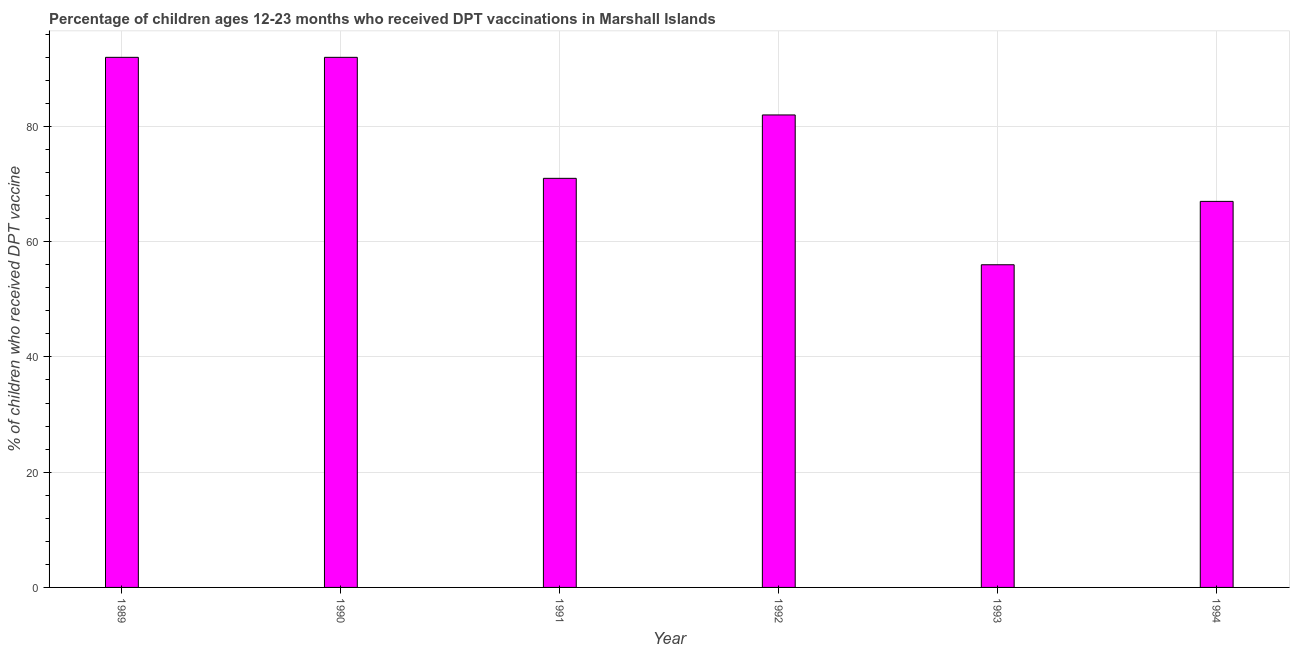Does the graph contain any zero values?
Make the answer very short. No. Does the graph contain grids?
Your answer should be very brief. Yes. What is the title of the graph?
Offer a very short reply. Percentage of children ages 12-23 months who received DPT vaccinations in Marshall Islands. What is the label or title of the Y-axis?
Offer a very short reply. % of children who received DPT vaccine. What is the percentage of children who received dpt vaccine in 1993?
Your answer should be compact. 56. Across all years, what is the maximum percentage of children who received dpt vaccine?
Offer a very short reply. 92. In which year was the percentage of children who received dpt vaccine maximum?
Keep it short and to the point. 1989. In which year was the percentage of children who received dpt vaccine minimum?
Give a very brief answer. 1993. What is the sum of the percentage of children who received dpt vaccine?
Your response must be concise. 460. What is the median percentage of children who received dpt vaccine?
Your response must be concise. 76.5. What is the ratio of the percentage of children who received dpt vaccine in 1989 to that in 1991?
Offer a very short reply. 1.3. What is the difference between the highest and the second highest percentage of children who received dpt vaccine?
Offer a very short reply. 0. Are the values on the major ticks of Y-axis written in scientific E-notation?
Offer a very short reply. No. What is the % of children who received DPT vaccine in 1989?
Provide a short and direct response. 92. What is the % of children who received DPT vaccine in 1990?
Give a very brief answer. 92. What is the % of children who received DPT vaccine of 1991?
Give a very brief answer. 71. What is the % of children who received DPT vaccine of 1993?
Your response must be concise. 56. What is the % of children who received DPT vaccine in 1994?
Give a very brief answer. 67. What is the difference between the % of children who received DPT vaccine in 1989 and 1990?
Make the answer very short. 0. What is the difference between the % of children who received DPT vaccine in 1989 and 1993?
Give a very brief answer. 36. What is the difference between the % of children who received DPT vaccine in 1990 and 1991?
Your answer should be compact. 21. What is the difference between the % of children who received DPT vaccine in 1990 and 1993?
Your response must be concise. 36. What is the difference between the % of children who received DPT vaccine in 1990 and 1994?
Offer a very short reply. 25. What is the difference between the % of children who received DPT vaccine in 1991 and 1993?
Provide a succinct answer. 15. What is the difference between the % of children who received DPT vaccine in 1991 and 1994?
Make the answer very short. 4. What is the difference between the % of children who received DPT vaccine in 1992 and 1994?
Your answer should be very brief. 15. What is the ratio of the % of children who received DPT vaccine in 1989 to that in 1991?
Your answer should be compact. 1.3. What is the ratio of the % of children who received DPT vaccine in 1989 to that in 1992?
Give a very brief answer. 1.12. What is the ratio of the % of children who received DPT vaccine in 1989 to that in 1993?
Your answer should be very brief. 1.64. What is the ratio of the % of children who received DPT vaccine in 1989 to that in 1994?
Offer a terse response. 1.37. What is the ratio of the % of children who received DPT vaccine in 1990 to that in 1991?
Provide a succinct answer. 1.3. What is the ratio of the % of children who received DPT vaccine in 1990 to that in 1992?
Offer a very short reply. 1.12. What is the ratio of the % of children who received DPT vaccine in 1990 to that in 1993?
Your answer should be compact. 1.64. What is the ratio of the % of children who received DPT vaccine in 1990 to that in 1994?
Provide a short and direct response. 1.37. What is the ratio of the % of children who received DPT vaccine in 1991 to that in 1992?
Keep it short and to the point. 0.87. What is the ratio of the % of children who received DPT vaccine in 1991 to that in 1993?
Provide a succinct answer. 1.27. What is the ratio of the % of children who received DPT vaccine in 1991 to that in 1994?
Provide a succinct answer. 1.06. What is the ratio of the % of children who received DPT vaccine in 1992 to that in 1993?
Give a very brief answer. 1.46. What is the ratio of the % of children who received DPT vaccine in 1992 to that in 1994?
Your answer should be compact. 1.22. What is the ratio of the % of children who received DPT vaccine in 1993 to that in 1994?
Ensure brevity in your answer.  0.84. 